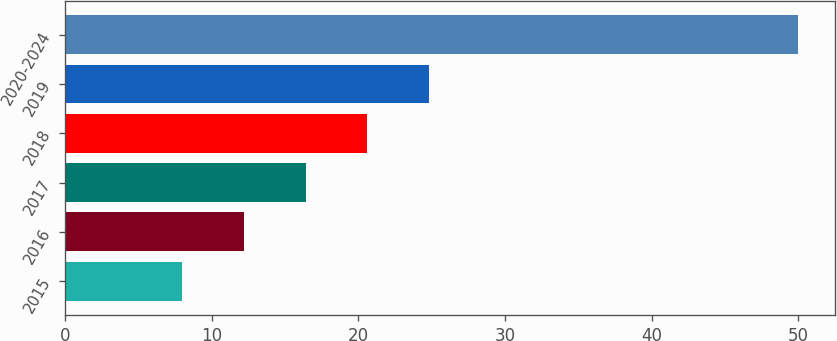Convert chart. <chart><loc_0><loc_0><loc_500><loc_500><bar_chart><fcel>2015<fcel>2016<fcel>2017<fcel>2018<fcel>2019<fcel>2020-2024<nl><fcel>8<fcel>12.2<fcel>16.4<fcel>20.6<fcel>24.8<fcel>50<nl></chart> 